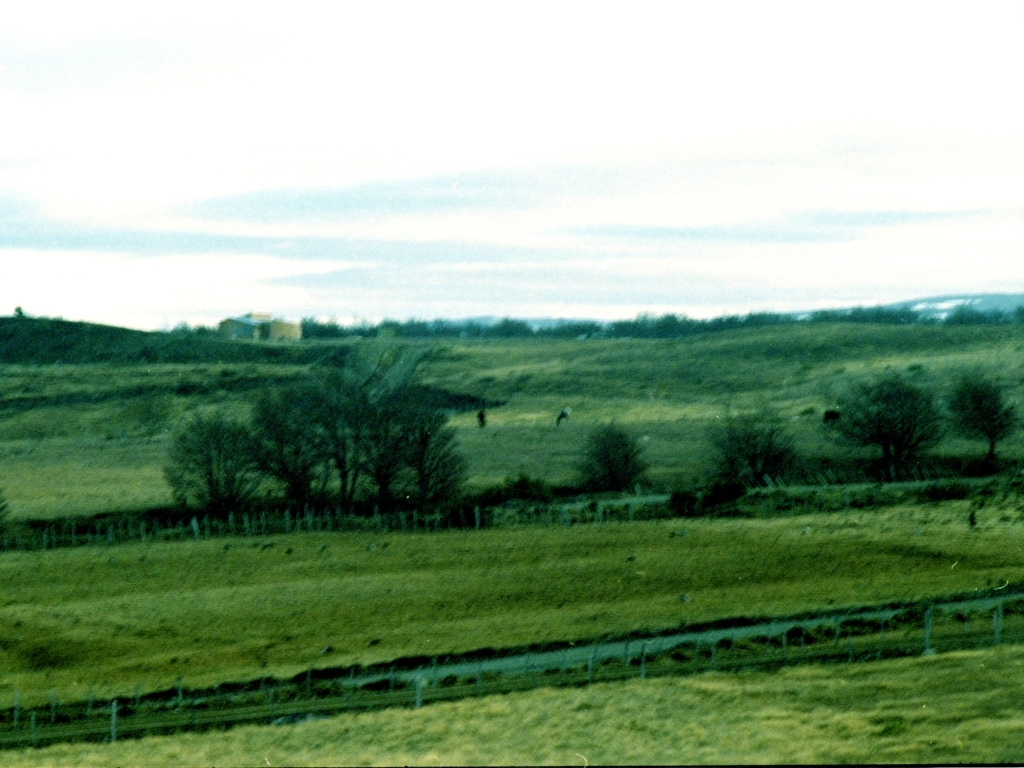Can you describe the landscape featured in this image? The landscape is comprised of open fields, undulating hills, and sparse vegetation. Fences demarcate sections of the land, and a few trees stand out against a mostly grass-covered terrain. It's a rural scene that might be used for grazing livestock. 